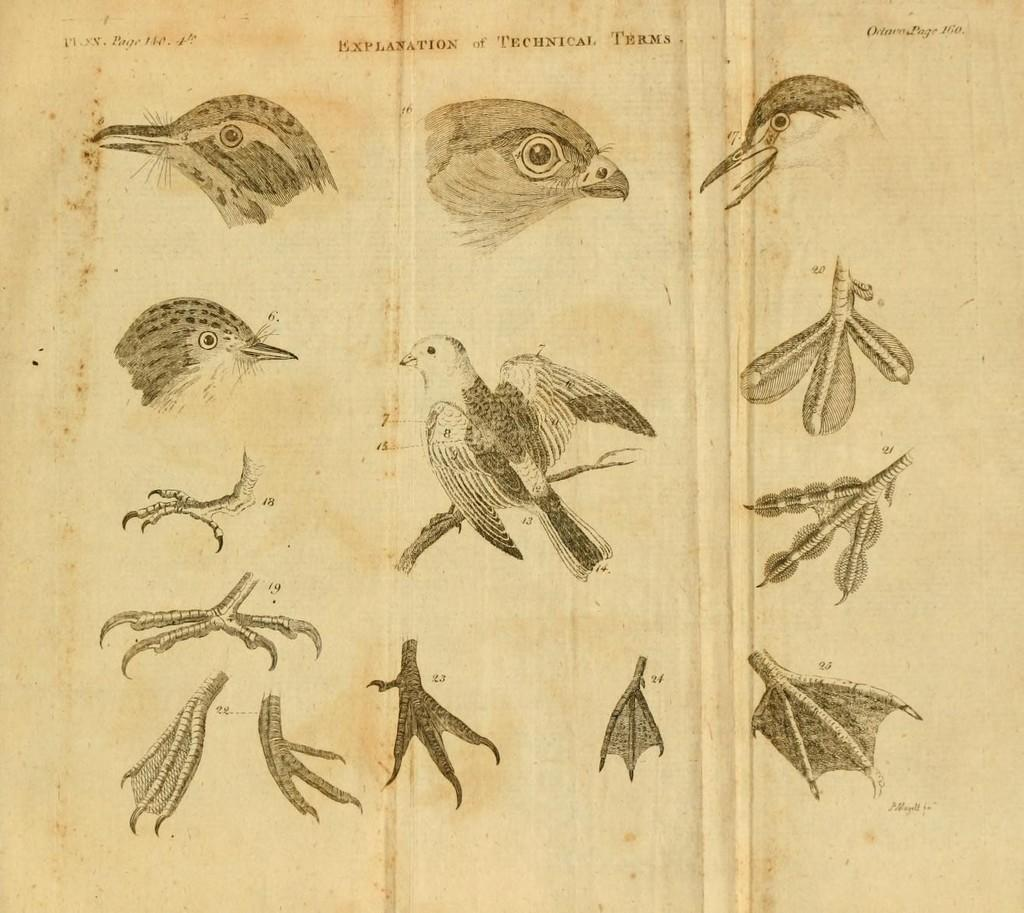What are the subjects of the drawings in the image? The drawings are of different birds. What color scheme is used for the drawings? The drawings are in black and white. What is the background color of the paper on which the drawings are made? The drawings are on a white paper. How does the tent survive the earthquake in the image? There is no tent or earthquake present in the image; the drawings are of different birds on a white paper. What type of hen is depicted in the image? There is no hen present in the image; the drawings are of different birds. 